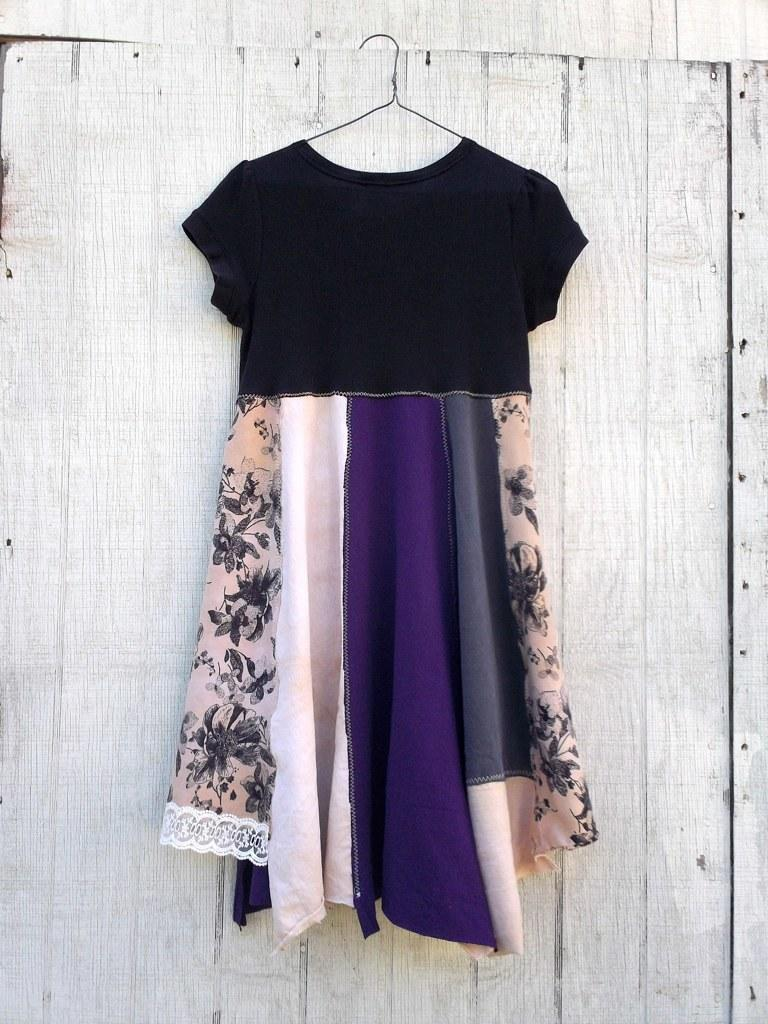What is hanging on the hanger in the image? There is a dress on a hanger in the image. Where is the dress located in relation to the wall? The dress is in front of a wooden wall in the background of the image. What type of committee is meeting in the image? There is no committee meeting in the image; it only features a dress on a hanger in front of a wooden wall. 